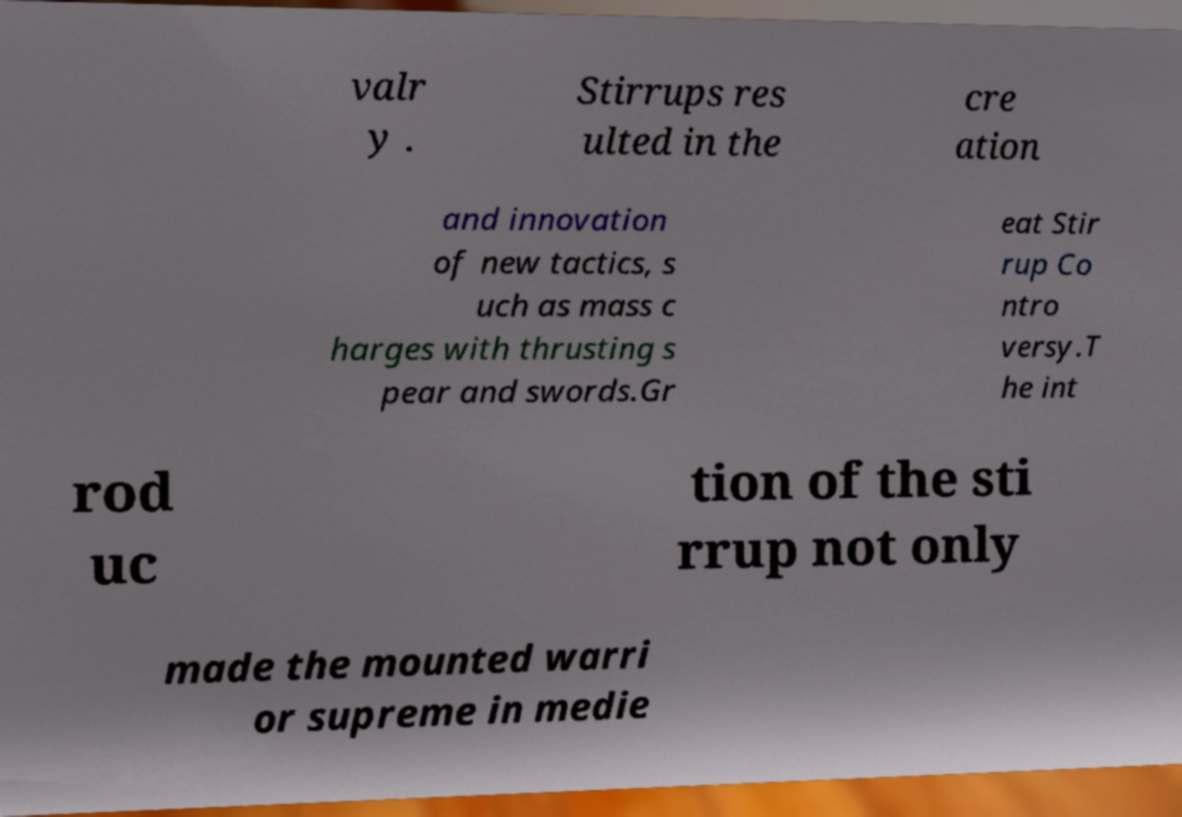Please identify and transcribe the text found in this image. valr y . Stirrups res ulted in the cre ation and innovation of new tactics, s uch as mass c harges with thrusting s pear and swords.Gr eat Stir rup Co ntro versy.T he int rod uc tion of the sti rrup not only made the mounted warri or supreme in medie 